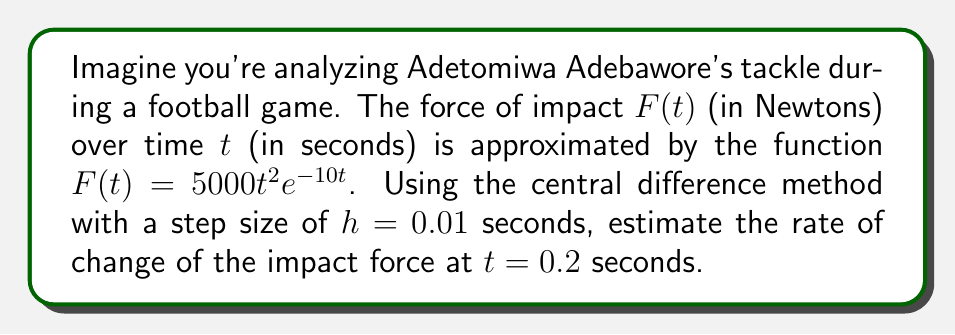Provide a solution to this math problem. To solve this problem, we'll use the central difference method to approximate the derivative of $F(t)$ at $t = 0.2$ seconds. The formula for the central difference approximation is:

$$F'(t) \approx \frac{F(t+h) - F(t-h)}{2h}$$

where $h = 0.01$ is the given step size.

Step 1: Calculate $F(t+h)$ and $F(t-h)$
$t+h = 0.2 + 0.01 = 0.21$
$t-h = 0.2 - 0.01 = 0.19$

$F(0.21) = 5000(0.21)^2e^{-10(0.21)}$
$F(0.19) = 5000(0.19)^2e^{-10(0.19)}$

Step 2: Substitute these values into the central difference formula

$$F'(0.2) \approx \frac{F(0.21) - F(0.19)}{2(0.01)}$$

$$F'(0.2) \approx \frac{5000(0.21)^2e^{-10(0.21)} - 5000(0.19)^2e^{-10(0.19)}}{0.02}$$

Step 3: Evaluate the expression

$F(0.21) = 5000(0.21)^2e^{-10(0.21)} \approx 131.8915$
$F(0.19) = 5000(0.19)^2e^{-10(0.19)} \approx 122.9679$

$$F'(0.2) \approx \frac{131.8915 - 122.9679}{0.02} \approx 446.18$$

Therefore, the estimated rate of change of the impact force at $t = 0.2$ seconds is approximately 446.18 N/s.
Answer: 446.18 N/s 